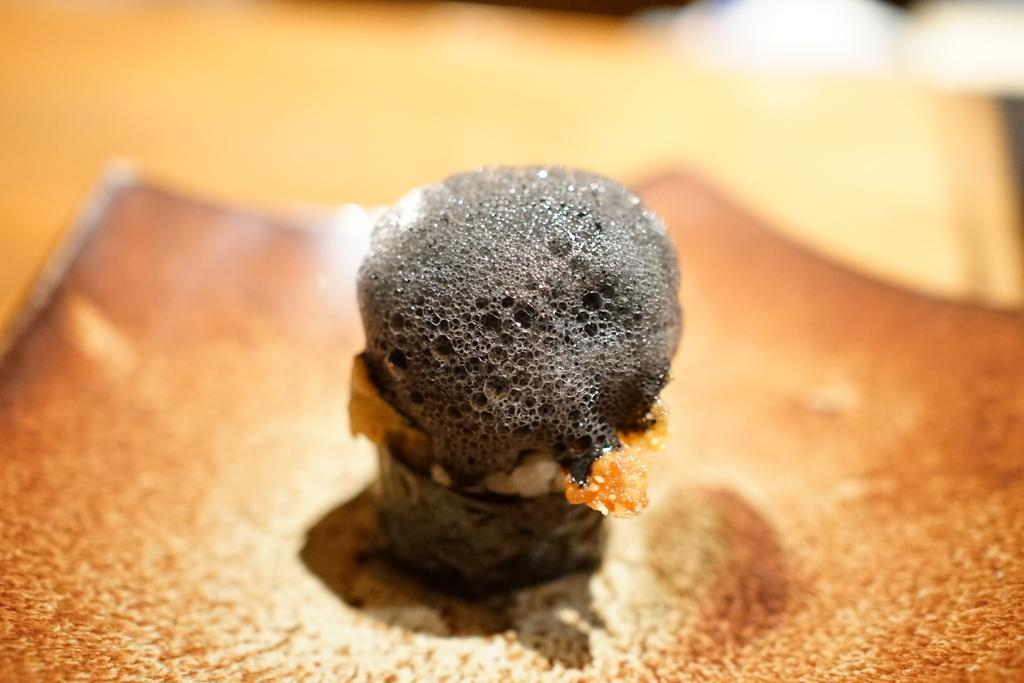What is the main subject in the foreground of the image? There is a dessert in the foreground of the image. Can you describe the background of the image? The background of the image is blurred. Where is the giraffe located in the image? There is no giraffe present in the image. What type of arch can be seen in the background of the image? There is no arch visible in the image, as the background is blurred. 